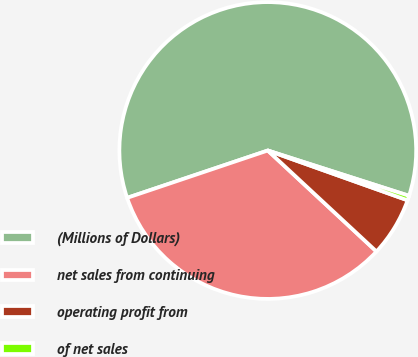Convert chart. <chart><loc_0><loc_0><loc_500><loc_500><pie_chart><fcel>(Millions of Dollars)<fcel>net sales from continuing<fcel>operating profit from<fcel>of net sales<nl><fcel>60.11%<fcel>32.92%<fcel>6.47%<fcel>0.51%<nl></chart> 